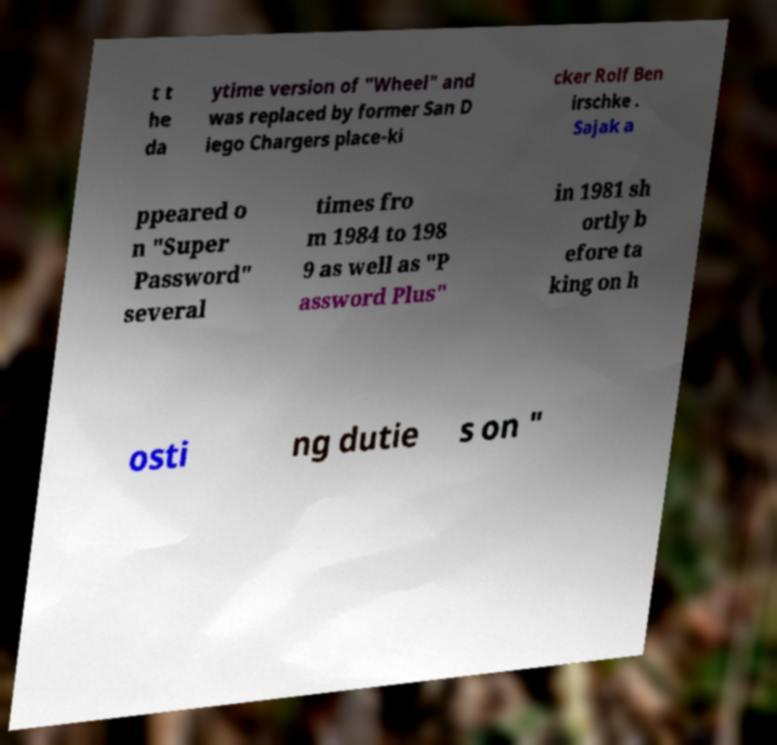Could you assist in decoding the text presented in this image and type it out clearly? t t he da ytime version of "Wheel" and was replaced by former San D iego Chargers place-ki cker Rolf Ben irschke . Sajak a ppeared o n "Super Password" several times fro m 1984 to 198 9 as well as "P assword Plus" in 1981 sh ortly b efore ta king on h osti ng dutie s on " 